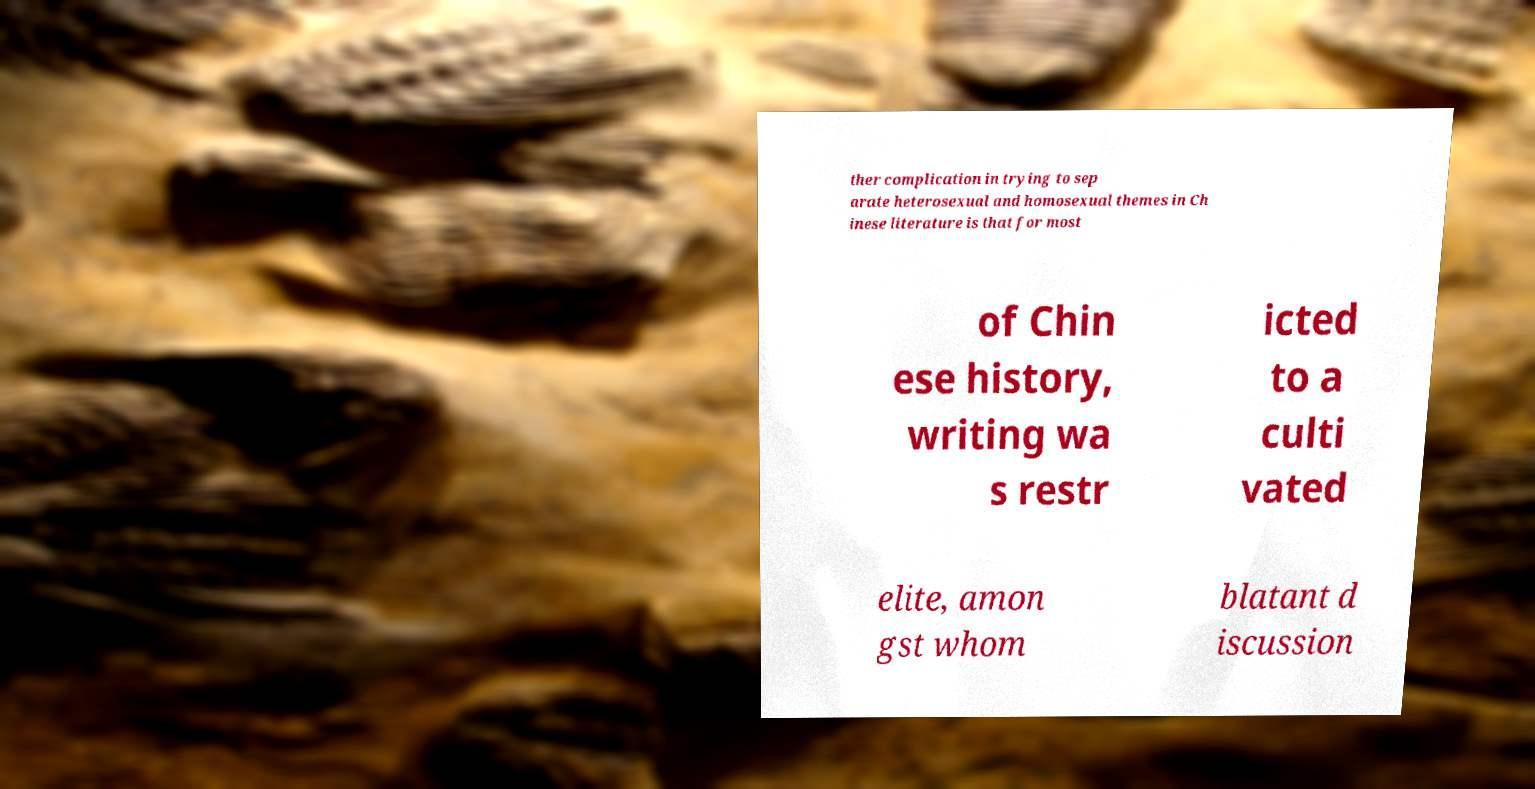I need the written content from this picture converted into text. Can you do that? ther complication in trying to sep arate heterosexual and homosexual themes in Ch inese literature is that for most of Chin ese history, writing wa s restr icted to a culti vated elite, amon gst whom blatant d iscussion 